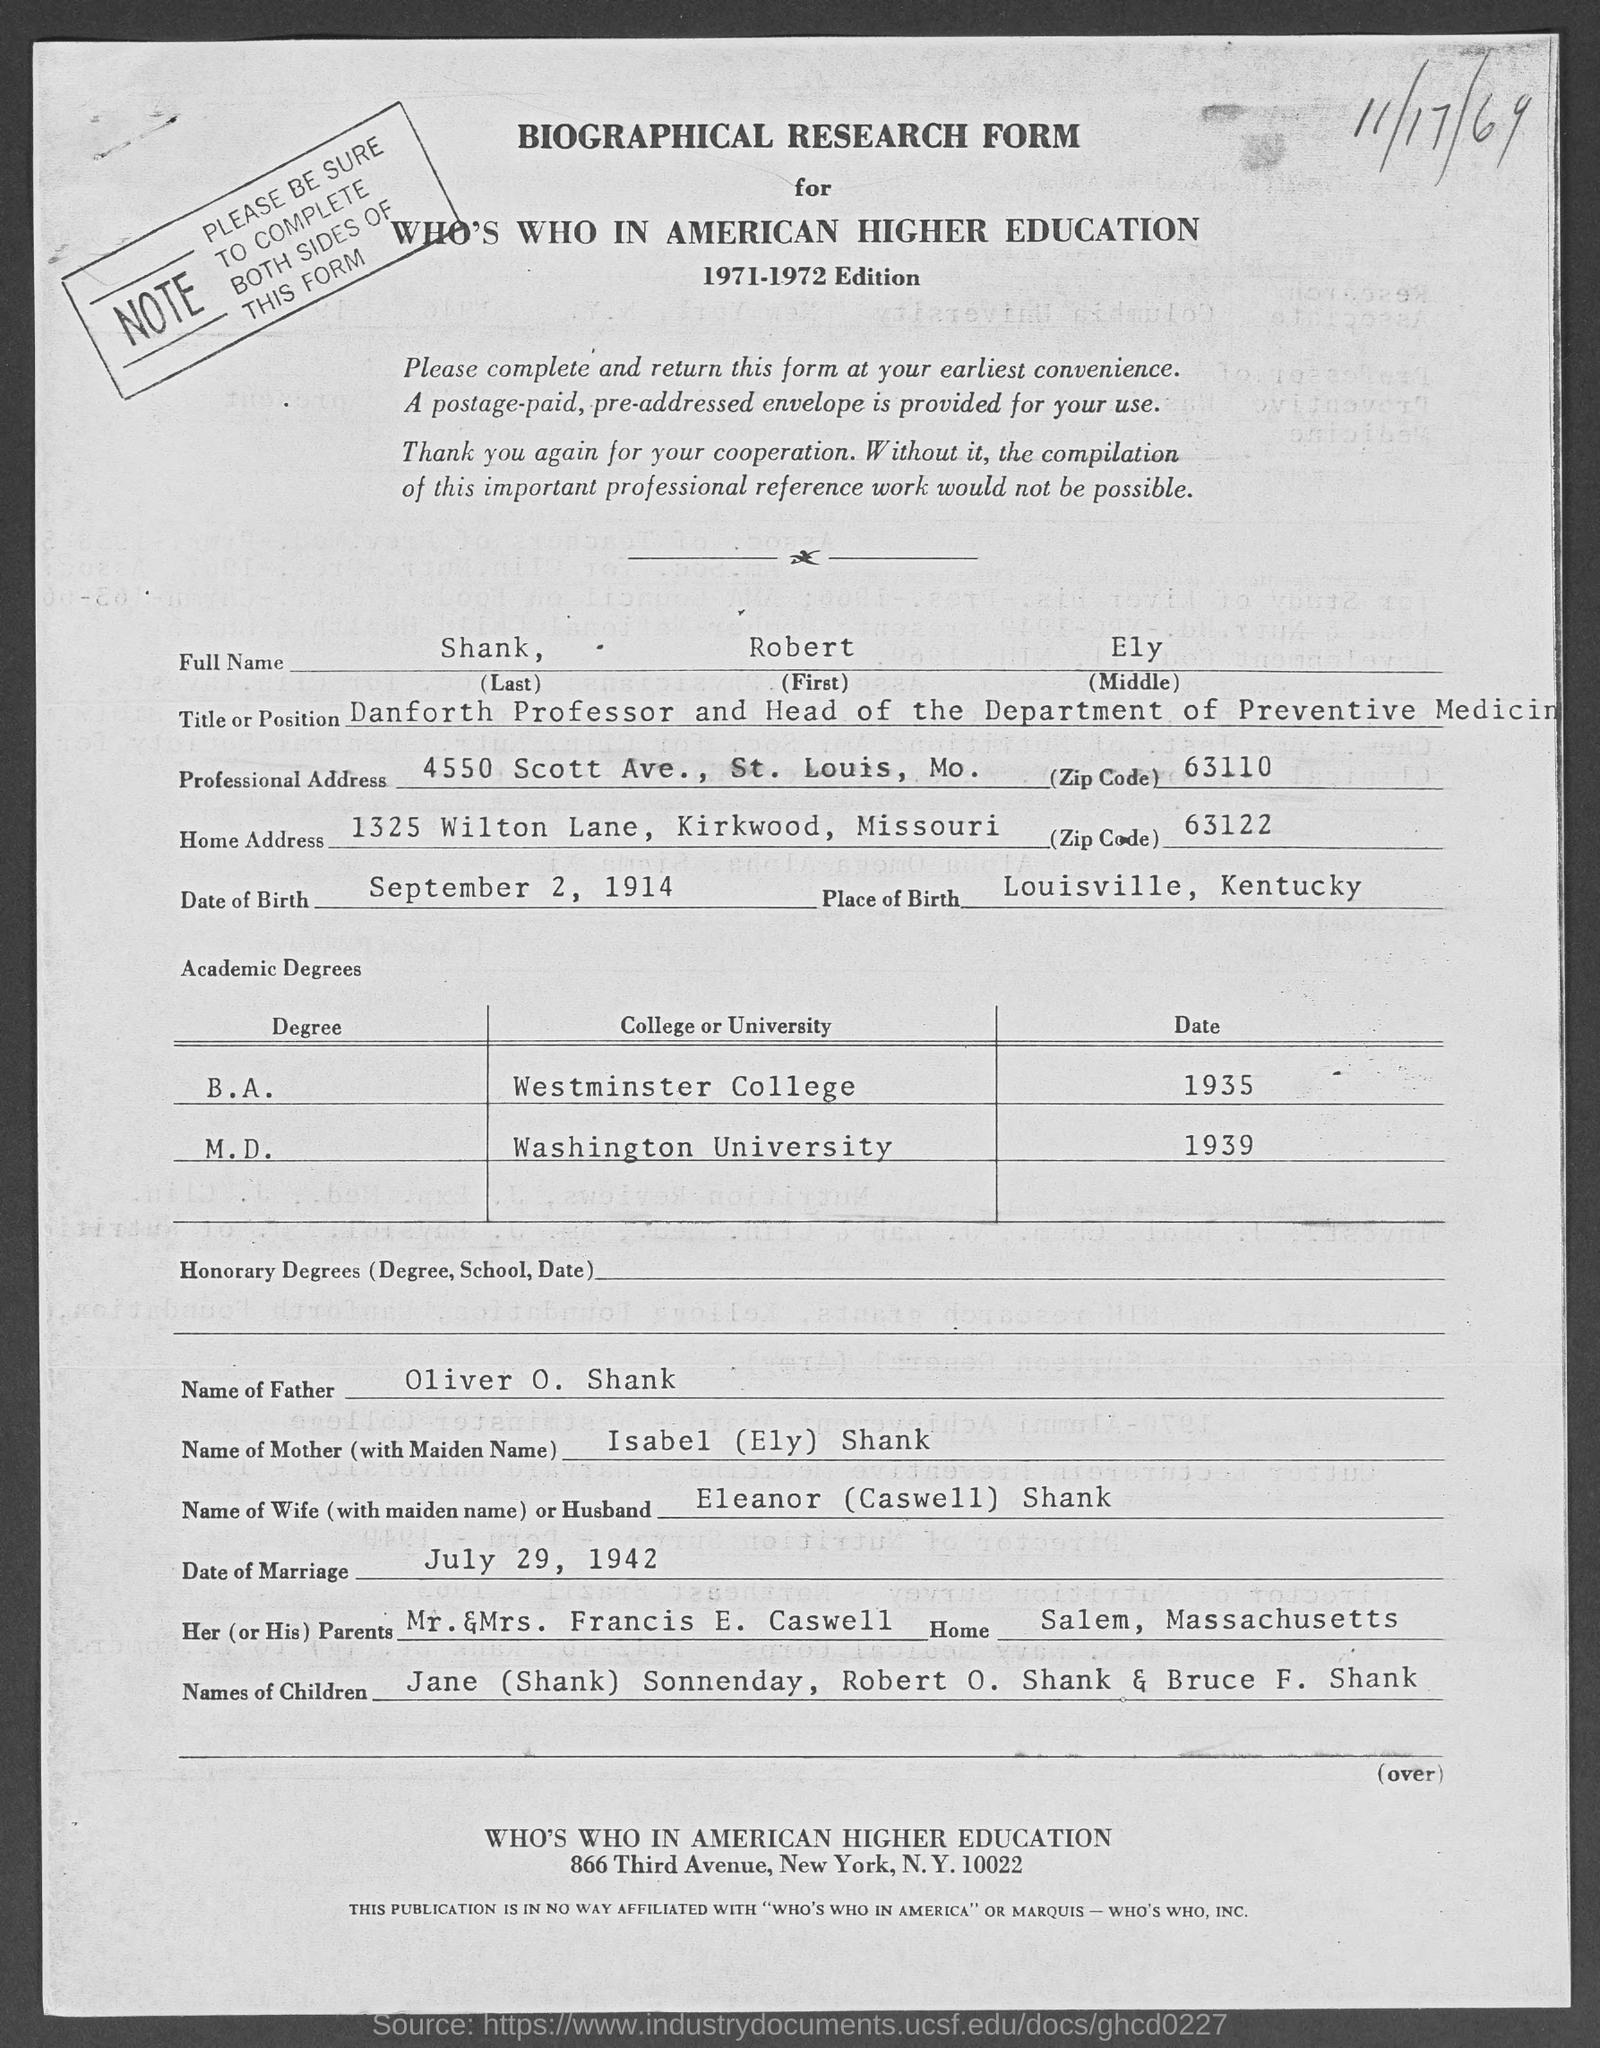What is the name of the form mentioned in the given page ?
Give a very brief answer. BIOGRAPHICAL RESEARCH FORM. What is the last name mentioned in the given form ?
Ensure brevity in your answer.  Shank. What is the first name mentioned in the given form ?
Your answer should be very brief. Robert. What is the middle name mentioned in the given form ?
Your answer should be very brief. Ely. What is the title or position mentioned in the given form ?
Ensure brevity in your answer.  Danforth Professor and Head of the Department of Preventive Medicine. What is the zip cod given for professional address as mentioned in the given form ?
Give a very brief answer. 63110. What is the zip cod given for home address as mentioned in the given form ?
Your answer should be compact. 63122. What is the name of the father mentioned in the given form ?
Provide a short and direct response. Oliver O. Shank. What is the date of marriage mentioned in the given form ?
Ensure brevity in your answer.  July 29, 1942. What is the name of the mother mentioned in the given form ?
Offer a terse response. Isabel (Ely) Shank. 